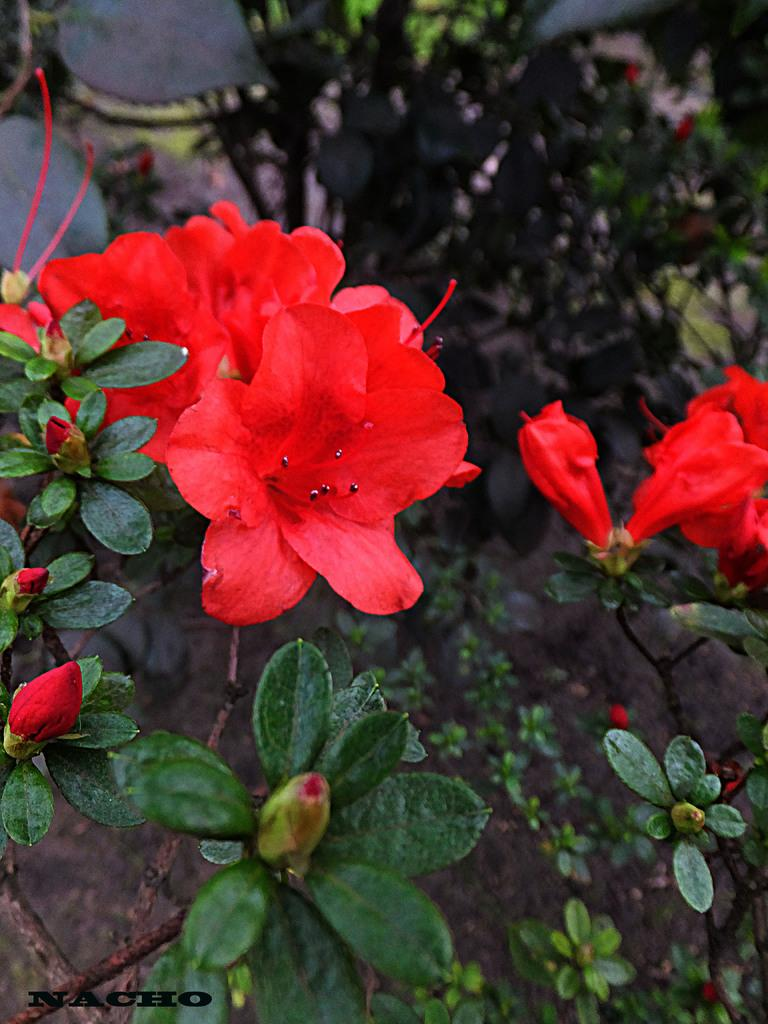What type of living organisms can be seen in the image? There are flowers and plants visible in the image. What can be found on the ground in the image? There are stones on the ground in the image. Is there any text present in the image? Yes, there is text visible in the bottom left of the image. How does the bone affect the acoustics in the image? There is no bone present in the image, so it cannot affect the acoustics. 